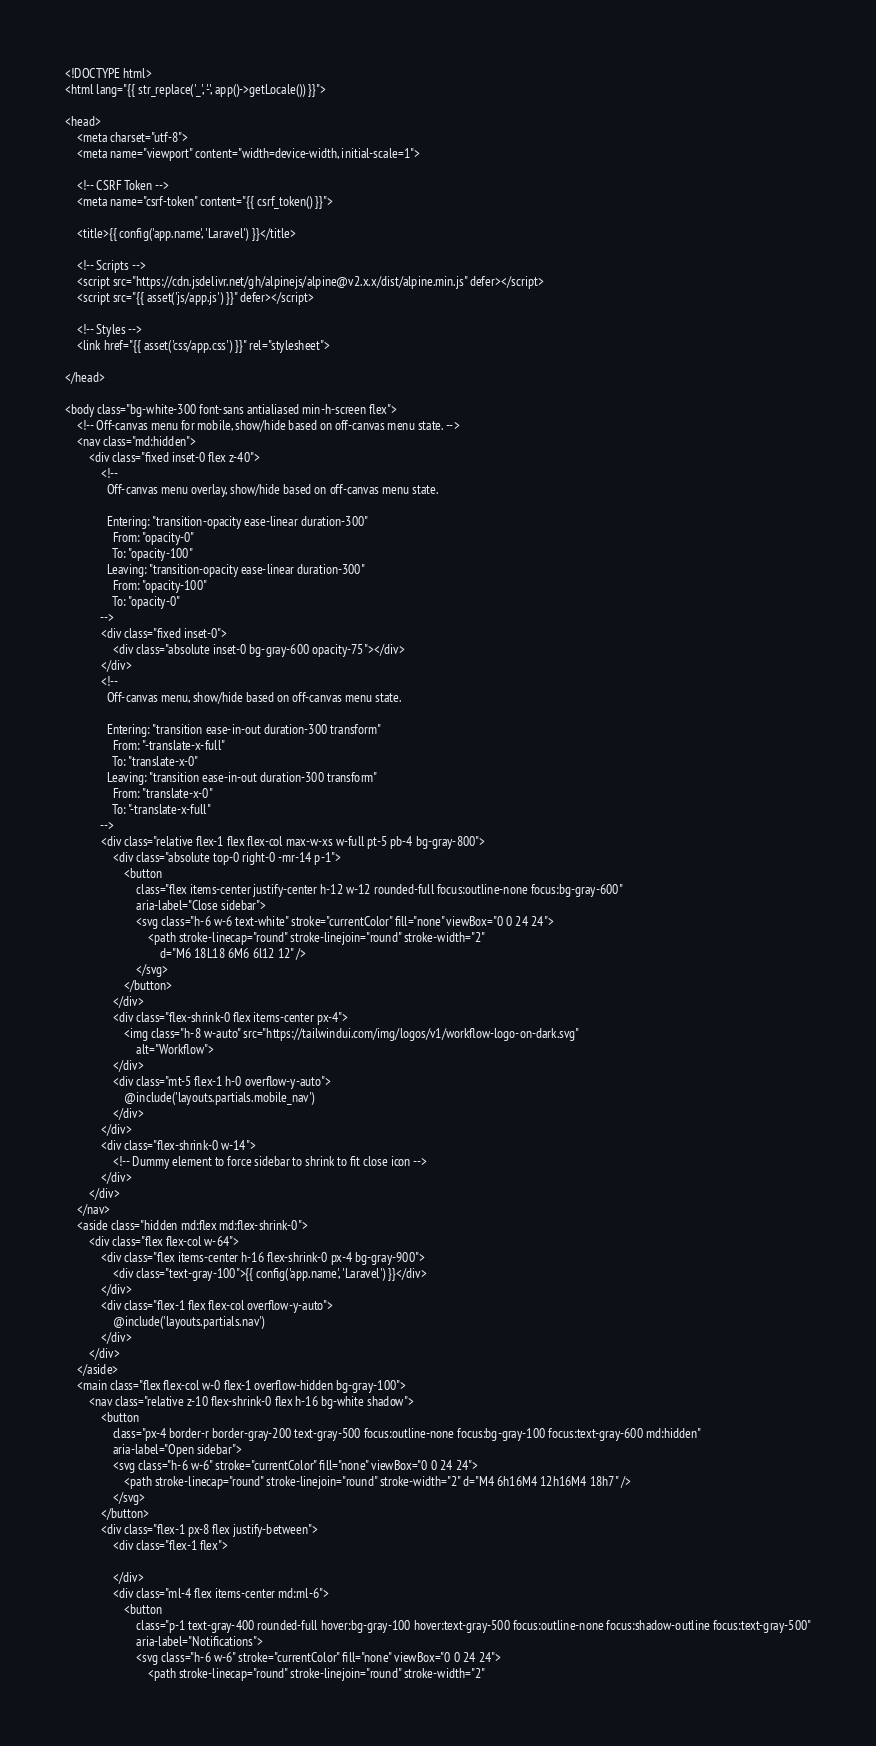Convert code to text. <code><loc_0><loc_0><loc_500><loc_500><_PHP_><!DOCTYPE html>
<html lang="{{ str_replace('_', '-', app()->getLocale()) }}">

<head>
    <meta charset="utf-8">
    <meta name="viewport" content="width=device-width, initial-scale=1">

    <!-- CSRF Token -->
    <meta name="csrf-token" content="{{ csrf_token() }}">

    <title>{{ config('app.name', 'Laravel') }}</title>

    <!-- Scripts -->
    <script src="https://cdn.jsdelivr.net/gh/alpinejs/alpine@v2.x.x/dist/alpine.min.js" defer></script>
    <script src="{{ asset('js/app.js') }}" defer></script>

    <!-- Styles -->
    <link href="{{ asset('css/app.css') }}" rel="stylesheet">

</head>

<body class="bg-white-300 font-sans antialiased min-h-screen flex">
    <!-- Off-canvas menu for mobile, show/hide based on off-canvas menu state. -->
    <nav class="md:hidden">
        <div class="fixed inset-0 flex z-40">
            <!--
              Off-canvas menu overlay, show/hide based on off-canvas menu state.

              Entering: "transition-opacity ease-linear duration-300"
                From: "opacity-0"
                To: "opacity-100"
              Leaving: "transition-opacity ease-linear duration-300"
                From: "opacity-100"
                To: "opacity-0"
            -->
            <div class="fixed inset-0">
                <div class="absolute inset-0 bg-gray-600 opacity-75"></div>
            </div>
            <!--
              Off-canvas menu, show/hide based on off-canvas menu state.

              Entering: "transition ease-in-out duration-300 transform"
                From: "-translate-x-full"
                To: "translate-x-0"
              Leaving: "transition ease-in-out duration-300 transform"
                From: "translate-x-0"
                To: "-translate-x-full"
            -->
            <div class="relative flex-1 flex flex-col max-w-xs w-full pt-5 pb-4 bg-gray-800">
                <div class="absolute top-0 right-0 -mr-14 p-1">
                    <button
                        class="flex items-center justify-center h-12 w-12 rounded-full focus:outline-none focus:bg-gray-600"
                        aria-label="Close sidebar">
                        <svg class="h-6 w-6 text-white" stroke="currentColor" fill="none" viewBox="0 0 24 24">
                            <path stroke-linecap="round" stroke-linejoin="round" stroke-width="2"
                                d="M6 18L18 6M6 6l12 12" />
                        </svg>
                    </button>
                </div>
                <div class="flex-shrink-0 flex items-center px-4">
                    <img class="h-8 w-auto" src="https://tailwindui.com/img/logos/v1/workflow-logo-on-dark.svg"
                        alt="Workflow">
                </div>
                <div class="mt-5 flex-1 h-0 overflow-y-auto">
                    @include('layouts.partials.mobile_nav')
                </div>
            </div>
            <div class="flex-shrink-0 w-14">
                <!-- Dummy element to force sidebar to shrink to fit close icon -->
            </div>
        </div>
    </nav>
    <aside class="hidden md:flex md:flex-shrink-0">
        <div class="flex flex-col w-64">
            <div class="flex items-center h-16 flex-shrink-0 px-4 bg-gray-900">
                <div class="text-gray-100">{{ config('app.name', 'Laravel') }}</div>
            </div>
            <div class="flex-1 flex flex-col overflow-y-auto">
                @include('layouts.partials.nav')
            </div>
        </div>
    </aside>
    <main class="flex flex-col w-0 flex-1 overflow-hidden bg-gray-100">
        <nav class="relative z-10 flex-shrink-0 flex h-16 bg-white shadow">
            <button
                class="px-4 border-r border-gray-200 text-gray-500 focus:outline-none focus:bg-gray-100 focus:text-gray-600 md:hidden"
                aria-label="Open sidebar">
                <svg class="h-6 w-6" stroke="currentColor" fill="none" viewBox="0 0 24 24">
                    <path stroke-linecap="round" stroke-linejoin="round" stroke-width="2" d="M4 6h16M4 12h16M4 18h7" />
                </svg>
            </button>
            <div class="flex-1 px-8 flex justify-between">
                <div class="flex-1 flex">

                </div>
                <div class="ml-4 flex items-center md:ml-6">
                    <button
                        class="p-1 text-gray-400 rounded-full hover:bg-gray-100 hover:text-gray-500 focus:outline-none focus:shadow-outline focus:text-gray-500"
                        aria-label="Notifications">
                        <svg class="h-6 w-6" stroke="currentColor" fill="none" viewBox="0 0 24 24">
                            <path stroke-linecap="round" stroke-linejoin="round" stroke-width="2"</code> 